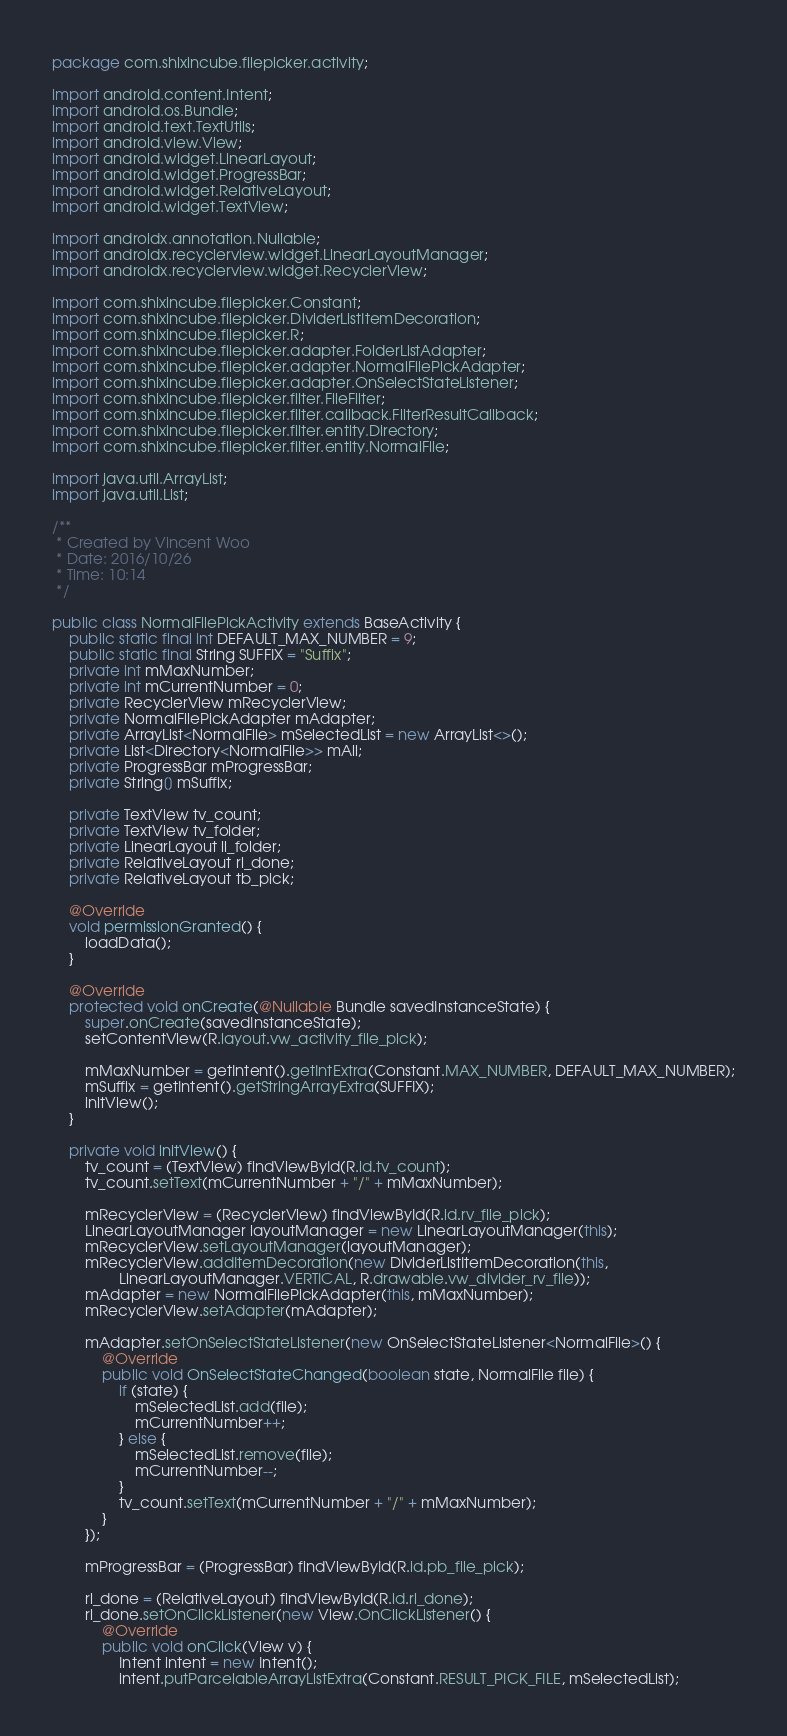Convert code to text. <code><loc_0><loc_0><loc_500><loc_500><_Java_>package com.shixincube.filepicker.activity;

import android.content.Intent;
import android.os.Bundle;
import android.text.TextUtils;
import android.view.View;
import android.widget.LinearLayout;
import android.widget.ProgressBar;
import android.widget.RelativeLayout;
import android.widget.TextView;

import androidx.annotation.Nullable;
import androidx.recyclerview.widget.LinearLayoutManager;
import androidx.recyclerview.widget.RecyclerView;

import com.shixincube.filepicker.Constant;
import com.shixincube.filepicker.DividerListItemDecoration;
import com.shixincube.filepicker.R;
import com.shixincube.filepicker.adapter.FolderListAdapter;
import com.shixincube.filepicker.adapter.NormalFilePickAdapter;
import com.shixincube.filepicker.adapter.OnSelectStateListener;
import com.shixincube.filepicker.filter.FileFilter;
import com.shixincube.filepicker.filter.callback.FilterResultCallback;
import com.shixincube.filepicker.filter.entity.Directory;
import com.shixincube.filepicker.filter.entity.NormalFile;

import java.util.ArrayList;
import java.util.List;

/**
 * Created by Vincent Woo
 * Date: 2016/10/26
 * Time: 10:14
 */

public class NormalFilePickActivity extends BaseActivity {
    public static final int DEFAULT_MAX_NUMBER = 9;
    public static final String SUFFIX = "Suffix";
    private int mMaxNumber;
    private int mCurrentNumber = 0;
    private RecyclerView mRecyclerView;
    private NormalFilePickAdapter mAdapter;
    private ArrayList<NormalFile> mSelectedList = new ArrayList<>();
    private List<Directory<NormalFile>> mAll;
    private ProgressBar mProgressBar;
    private String[] mSuffix;

    private TextView tv_count;
    private TextView tv_folder;
    private LinearLayout ll_folder;
    private RelativeLayout rl_done;
    private RelativeLayout tb_pick;

    @Override
    void permissionGranted() {
        loadData();
    }

    @Override
    protected void onCreate(@Nullable Bundle savedInstanceState) {
        super.onCreate(savedInstanceState);
        setContentView(R.layout.vw_activity_file_pick);

        mMaxNumber = getIntent().getIntExtra(Constant.MAX_NUMBER, DEFAULT_MAX_NUMBER);
        mSuffix = getIntent().getStringArrayExtra(SUFFIX);
        initView();
    }

    private void initView() {
        tv_count = (TextView) findViewById(R.id.tv_count);
        tv_count.setText(mCurrentNumber + "/" + mMaxNumber);

        mRecyclerView = (RecyclerView) findViewById(R.id.rv_file_pick);
        LinearLayoutManager layoutManager = new LinearLayoutManager(this);
        mRecyclerView.setLayoutManager(layoutManager);
        mRecyclerView.addItemDecoration(new DividerListItemDecoration(this,
                LinearLayoutManager.VERTICAL, R.drawable.vw_divider_rv_file));
        mAdapter = new NormalFilePickAdapter(this, mMaxNumber);
        mRecyclerView.setAdapter(mAdapter);

        mAdapter.setOnSelectStateListener(new OnSelectStateListener<NormalFile>() {
            @Override
            public void OnSelectStateChanged(boolean state, NormalFile file) {
                if (state) {
                    mSelectedList.add(file);
                    mCurrentNumber++;
                } else {
                    mSelectedList.remove(file);
                    mCurrentNumber--;
                }
                tv_count.setText(mCurrentNumber + "/" + mMaxNumber);
            }
        });

        mProgressBar = (ProgressBar) findViewById(R.id.pb_file_pick);

        rl_done = (RelativeLayout) findViewById(R.id.rl_done);
        rl_done.setOnClickListener(new View.OnClickListener() {
            @Override
            public void onClick(View v) {
                Intent intent = new Intent();
                intent.putParcelableArrayListExtra(Constant.RESULT_PICK_FILE, mSelectedList);</code> 